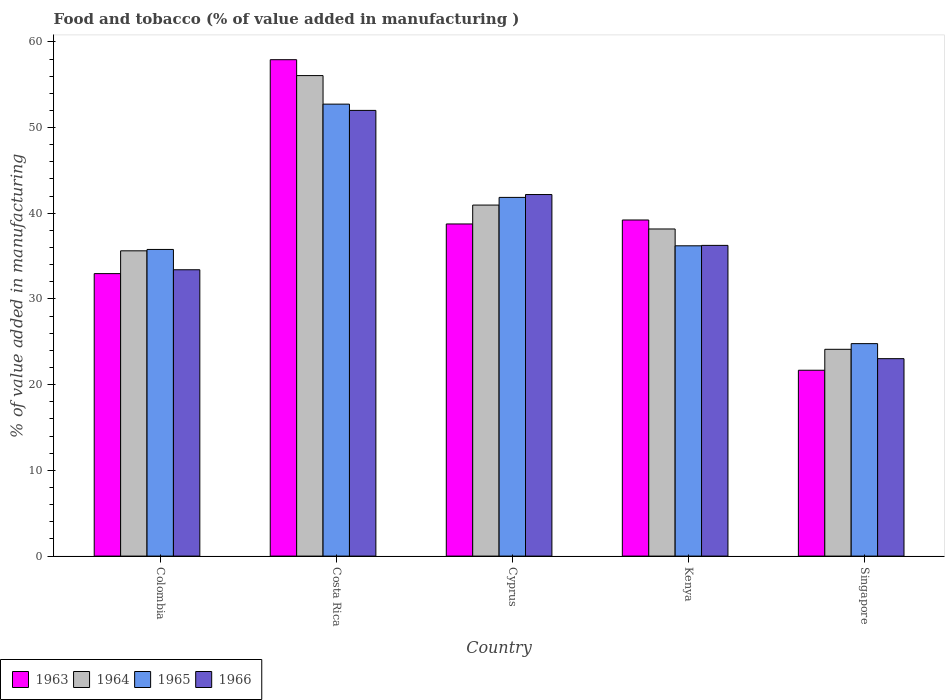How many groups of bars are there?
Ensure brevity in your answer.  5. Are the number of bars on each tick of the X-axis equal?
Make the answer very short. Yes. How many bars are there on the 2nd tick from the right?
Offer a very short reply. 4. What is the label of the 3rd group of bars from the left?
Offer a very short reply. Cyprus. What is the value added in manufacturing food and tobacco in 1964 in Cyprus?
Offer a very short reply. 40.96. Across all countries, what is the maximum value added in manufacturing food and tobacco in 1964?
Give a very brief answer. 56.07. Across all countries, what is the minimum value added in manufacturing food and tobacco in 1966?
Your answer should be very brief. 23.04. In which country was the value added in manufacturing food and tobacco in 1965 minimum?
Your answer should be very brief. Singapore. What is the total value added in manufacturing food and tobacco in 1964 in the graph?
Your answer should be very brief. 194.94. What is the difference between the value added in manufacturing food and tobacco in 1965 in Kenya and that in Singapore?
Provide a succinct answer. 11.41. What is the difference between the value added in manufacturing food and tobacco in 1964 in Costa Rica and the value added in manufacturing food and tobacco in 1965 in Singapore?
Offer a very short reply. 31.28. What is the average value added in manufacturing food and tobacco in 1966 per country?
Offer a terse response. 37.38. What is the difference between the value added in manufacturing food and tobacco of/in 1964 and value added in manufacturing food and tobacco of/in 1966 in Kenya?
Make the answer very short. 1.91. In how many countries, is the value added in manufacturing food and tobacco in 1965 greater than 50 %?
Your answer should be very brief. 1. What is the ratio of the value added in manufacturing food and tobacco in 1964 in Colombia to that in Singapore?
Give a very brief answer. 1.48. Is the difference between the value added in manufacturing food and tobacco in 1964 in Costa Rica and Kenya greater than the difference between the value added in manufacturing food and tobacco in 1966 in Costa Rica and Kenya?
Offer a terse response. Yes. What is the difference between the highest and the second highest value added in manufacturing food and tobacco in 1966?
Your answer should be compact. -9.82. What is the difference between the highest and the lowest value added in manufacturing food and tobacco in 1966?
Your response must be concise. 28.97. What does the 3rd bar from the left in Kenya represents?
Your response must be concise. 1965. What does the 1st bar from the right in Singapore represents?
Provide a succinct answer. 1966. Is it the case that in every country, the sum of the value added in manufacturing food and tobacco in 1966 and value added in manufacturing food and tobacco in 1963 is greater than the value added in manufacturing food and tobacco in 1964?
Offer a very short reply. Yes. Are all the bars in the graph horizontal?
Make the answer very short. No. How many countries are there in the graph?
Ensure brevity in your answer.  5. Does the graph contain any zero values?
Provide a succinct answer. No. Does the graph contain grids?
Your answer should be very brief. No. Where does the legend appear in the graph?
Offer a very short reply. Bottom left. What is the title of the graph?
Provide a succinct answer. Food and tobacco (% of value added in manufacturing ). Does "1995" appear as one of the legend labels in the graph?
Make the answer very short. No. What is the label or title of the Y-axis?
Offer a very short reply. % of value added in manufacturing. What is the % of value added in manufacturing in 1963 in Colombia?
Ensure brevity in your answer.  32.96. What is the % of value added in manufacturing of 1964 in Colombia?
Keep it short and to the point. 35.62. What is the % of value added in manufacturing of 1965 in Colombia?
Give a very brief answer. 35.78. What is the % of value added in manufacturing in 1966 in Colombia?
Your response must be concise. 33.41. What is the % of value added in manufacturing of 1963 in Costa Rica?
Give a very brief answer. 57.92. What is the % of value added in manufacturing in 1964 in Costa Rica?
Your answer should be compact. 56.07. What is the % of value added in manufacturing in 1965 in Costa Rica?
Keep it short and to the point. 52.73. What is the % of value added in manufacturing of 1966 in Costa Rica?
Provide a short and direct response. 52. What is the % of value added in manufacturing in 1963 in Cyprus?
Your answer should be very brief. 38.75. What is the % of value added in manufacturing of 1964 in Cyprus?
Make the answer very short. 40.96. What is the % of value added in manufacturing in 1965 in Cyprus?
Your answer should be very brief. 41.85. What is the % of value added in manufacturing of 1966 in Cyprus?
Offer a terse response. 42.19. What is the % of value added in manufacturing of 1963 in Kenya?
Your answer should be very brief. 39.22. What is the % of value added in manufacturing of 1964 in Kenya?
Offer a terse response. 38.17. What is the % of value added in manufacturing of 1965 in Kenya?
Provide a succinct answer. 36.2. What is the % of value added in manufacturing in 1966 in Kenya?
Give a very brief answer. 36.25. What is the % of value added in manufacturing of 1963 in Singapore?
Your response must be concise. 21.69. What is the % of value added in manufacturing of 1964 in Singapore?
Offer a terse response. 24.13. What is the % of value added in manufacturing of 1965 in Singapore?
Ensure brevity in your answer.  24.79. What is the % of value added in manufacturing in 1966 in Singapore?
Provide a succinct answer. 23.04. Across all countries, what is the maximum % of value added in manufacturing in 1963?
Your response must be concise. 57.92. Across all countries, what is the maximum % of value added in manufacturing in 1964?
Give a very brief answer. 56.07. Across all countries, what is the maximum % of value added in manufacturing of 1965?
Make the answer very short. 52.73. Across all countries, what is the maximum % of value added in manufacturing of 1966?
Your answer should be very brief. 52. Across all countries, what is the minimum % of value added in manufacturing of 1963?
Your answer should be compact. 21.69. Across all countries, what is the minimum % of value added in manufacturing of 1964?
Your answer should be compact. 24.13. Across all countries, what is the minimum % of value added in manufacturing of 1965?
Make the answer very short. 24.79. Across all countries, what is the minimum % of value added in manufacturing in 1966?
Your response must be concise. 23.04. What is the total % of value added in manufacturing of 1963 in the graph?
Make the answer very short. 190.54. What is the total % of value added in manufacturing in 1964 in the graph?
Make the answer very short. 194.94. What is the total % of value added in manufacturing in 1965 in the graph?
Offer a very short reply. 191.36. What is the total % of value added in manufacturing of 1966 in the graph?
Provide a succinct answer. 186.89. What is the difference between the % of value added in manufacturing in 1963 in Colombia and that in Costa Rica?
Provide a short and direct response. -24.96. What is the difference between the % of value added in manufacturing of 1964 in Colombia and that in Costa Rica?
Ensure brevity in your answer.  -20.45. What is the difference between the % of value added in manufacturing of 1965 in Colombia and that in Costa Rica?
Offer a terse response. -16.95. What is the difference between the % of value added in manufacturing of 1966 in Colombia and that in Costa Rica?
Give a very brief answer. -18.59. What is the difference between the % of value added in manufacturing of 1963 in Colombia and that in Cyprus?
Your answer should be compact. -5.79. What is the difference between the % of value added in manufacturing in 1964 in Colombia and that in Cyprus?
Your answer should be compact. -5.34. What is the difference between the % of value added in manufacturing in 1965 in Colombia and that in Cyprus?
Your answer should be compact. -6.07. What is the difference between the % of value added in manufacturing in 1966 in Colombia and that in Cyprus?
Your answer should be compact. -8.78. What is the difference between the % of value added in manufacturing of 1963 in Colombia and that in Kenya?
Ensure brevity in your answer.  -6.26. What is the difference between the % of value added in manufacturing of 1964 in Colombia and that in Kenya?
Ensure brevity in your answer.  -2.55. What is the difference between the % of value added in manufacturing in 1965 in Colombia and that in Kenya?
Keep it short and to the point. -0.42. What is the difference between the % of value added in manufacturing in 1966 in Colombia and that in Kenya?
Your answer should be very brief. -2.84. What is the difference between the % of value added in manufacturing in 1963 in Colombia and that in Singapore?
Your response must be concise. 11.27. What is the difference between the % of value added in manufacturing in 1964 in Colombia and that in Singapore?
Give a very brief answer. 11.49. What is the difference between the % of value added in manufacturing in 1965 in Colombia and that in Singapore?
Provide a short and direct response. 10.99. What is the difference between the % of value added in manufacturing in 1966 in Colombia and that in Singapore?
Make the answer very short. 10.37. What is the difference between the % of value added in manufacturing of 1963 in Costa Rica and that in Cyprus?
Ensure brevity in your answer.  19.17. What is the difference between the % of value added in manufacturing of 1964 in Costa Rica and that in Cyprus?
Ensure brevity in your answer.  15.11. What is the difference between the % of value added in manufacturing of 1965 in Costa Rica and that in Cyprus?
Make the answer very short. 10.88. What is the difference between the % of value added in manufacturing of 1966 in Costa Rica and that in Cyprus?
Ensure brevity in your answer.  9.82. What is the difference between the % of value added in manufacturing in 1963 in Costa Rica and that in Kenya?
Offer a very short reply. 18.7. What is the difference between the % of value added in manufacturing in 1964 in Costa Rica and that in Kenya?
Ensure brevity in your answer.  17.9. What is the difference between the % of value added in manufacturing of 1965 in Costa Rica and that in Kenya?
Your answer should be compact. 16.53. What is the difference between the % of value added in manufacturing in 1966 in Costa Rica and that in Kenya?
Your response must be concise. 15.75. What is the difference between the % of value added in manufacturing of 1963 in Costa Rica and that in Singapore?
Make the answer very short. 36.23. What is the difference between the % of value added in manufacturing in 1964 in Costa Rica and that in Singapore?
Provide a succinct answer. 31.94. What is the difference between the % of value added in manufacturing in 1965 in Costa Rica and that in Singapore?
Provide a succinct answer. 27.94. What is the difference between the % of value added in manufacturing in 1966 in Costa Rica and that in Singapore?
Offer a terse response. 28.97. What is the difference between the % of value added in manufacturing in 1963 in Cyprus and that in Kenya?
Provide a succinct answer. -0.46. What is the difference between the % of value added in manufacturing in 1964 in Cyprus and that in Kenya?
Your answer should be very brief. 2.79. What is the difference between the % of value added in manufacturing in 1965 in Cyprus and that in Kenya?
Ensure brevity in your answer.  5.65. What is the difference between the % of value added in manufacturing of 1966 in Cyprus and that in Kenya?
Offer a very short reply. 5.93. What is the difference between the % of value added in manufacturing in 1963 in Cyprus and that in Singapore?
Ensure brevity in your answer.  17.07. What is the difference between the % of value added in manufacturing in 1964 in Cyprus and that in Singapore?
Your response must be concise. 16.83. What is the difference between the % of value added in manufacturing of 1965 in Cyprus and that in Singapore?
Keep it short and to the point. 17.06. What is the difference between the % of value added in manufacturing in 1966 in Cyprus and that in Singapore?
Your answer should be compact. 19.15. What is the difference between the % of value added in manufacturing of 1963 in Kenya and that in Singapore?
Your answer should be very brief. 17.53. What is the difference between the % of value added in manufacturing in 1964 in Kenya and that in Singapore?
Your answer should be compact. 14.04. What is the difference between the % of value added in manufacturing in 1965 in Kenya and that in Singapore?
Your answer should be very brief. 11.41. What is the difference between the % of value added in manufacturing of 1966 in Kenya and that in Singapore?
Offer a very short reply. 13.22. What is the difference between the % of value added in manufacturing in 1963 in Colombia and the % of value added in manufacturing in 1964 in Costa Rica?
Provide a short and direct response. -23.11. What is the difference between the % of value added in manufacturing of 1963 in Colombia and the % of value added in manufacturing of 1965 in Costa Rica?
Keep it short and to the point. -19.77. What is the difference between the % of value added in manufacturing of 1963 in Colombia and the % of value added in manufacturing of 1966 in Costa Rica?
Your answer should be compact. -19.04. What is the difference between the % of value added in manufacturing in 1964 in Colombia and the % of value added in manufacturing in 1965 in Costa Rica?
Provide a short and direct response. -17.11. What is the difference between the % of value added in manufacturing of 1964 in Colombia and the % of value added in manufacturing of 1966 in Costa Rica?
Provide a short and direct response. -16.38. What is the difference between the % of value added in manufacturing in 1965 in Colombia and the % of value added in manufacturing in 1966 in Costa Rica?
Your response must be concise. -16.22. What is the difference between the % of value added in manufacturing of 1963 in Colombia and the % of value added in manufacturing of 1964 in Cyprus?
Your answer should be very brief. -8. What is the difference between the % of value added in manufacturing in 1963 in Colombia and the % of value added in manufacturing in 1965 in Cyprus?
Provide a succinct answer. -8.89. What is the difference between the % of value added in manufacturing of 1963 in Colombia and the % of value added in manufacturing of 1966 in Cyprus?
Offer a very short reply. -9.23. What is the difference between the % of value added in manufacturing of 1964 in Colombia and the % of value added in manufacturing of 1965 in Cyprus?
Ensure brevity in your answer.  -6.23. What is the difference between the % of value added in manufacturing in 1964 in Colombia and the % of value added in manufacturing in 1966 in Cyprus?
Your answer should be compact. -6.57. What is the difference between the % of value added in manufacturing in 1965 in Colombia and the % of value added in manufacturing in 1966 in Cyprus?
Give a very brief answer. -6.41. What is the difference between the % of value added in manufacturing of 1963 in Colombia and the % of value added in manufacturing of 1964 in Kenya?
Your answer should be very brief. -5.21. What is the difference between the % of value added in manufacturing in 1963 in Colombia and the % of value added in manufacturing in 1965 in Kenya?
Your answer should be compact. -3.24. What is the difference between the % of value added in manufacturing in 1963 in Colombia and the % of value added in manufacturing in 1966 in Kenya?
Offer a very short reply. -3.29. What is the difference between the % of value added in manufacturing of 1964 in Colombia and the % of value added in manufacturing of 1965 in Kenya?
Your response must be concise. -0.58. What is the difference between the % of value added in manufacturing in 1964 in Colombia and the % of value added in manufacturing in 1966 in Kenya?
Your answer should be compact. -0.63. What is the difference between the % of value added in manufacturing in 1965 in Colombia and the % of value added in manufacturing in 1966 in Kenya?
Provide a short and direct response. -0.47. What is the difference between the % of value added in manufacturing of 1963 in Colombia and the % of value added in manufacturing of 1964 in Singapore?
Keep it short and to the point. 8.83. What is the difference between the % of value added in manufacturing of 1963 in Colombia and the % of value added in manufacturing of 1965 in Singapore?
Offer a very short reply. 8.17. What is the difference between the % of value added in manufacturing in 1963 in Colombia and the % of value added in manufacturing in 1966 in Singapore?
Provide a short and direct response. 9.92. What is the difference between the % of value added in manufacturing of 1964 in Colombia and the % of value added in manufacturing of 1965 in Singapore?
Ensure brevity in your answer.  10.83. What is the difference between the % of value added in manufacturing in 1964 in Colombia and the % of value added in manufacturing in 1966 in Singapore?
Provide a succinct answer. 12.58. What is the difference between the % of value added in manufacturing in 1965 in Colombia and the % of value added in manufacturing in 1966 in Singapore?
Offer a terse response. 12.74. What is the difference between the % of value added in manufacturing in 1963 in Costa Rica and the % of value added in manufacturing in 1964 in Cyprus?
Give a very brief answer. 16.96. What is the difference between the % of value added in manufacturing of 1963 in Costa Rica and the % of value added in manufacturing of 1965 in Cyprus?
Your answer should be compact. 16.07. What is the difference between the % of value added in manufacturing in 1963 in Costa Rica and the % of value added in manufacturing in 1966 in Cyprus?
Give a very brief answer. 15.73. What is the difference between the % of value added in manufacturing of 1964 in Costa Rica and the % of value added in manufacturing of 1965 in Cyprus?
Give a very brief answer. 14.21. What is the difference between the % of value added in manufacturing in 1964 in Costa Rica and the % of value added in manufacturing in 1966 in Cyprus?
Your answer should be very brief. 13.88. What is the difference between the % of value added in manufacturing in 1965 in Costa Rica and the % of value added in manufacturing in 1966 in Cyprus?
Give a very brief answer. 10.55. What is the difference between the % of value added in manufacturing in 1963 in Costa Rica and the % of value added in manufacturing in 1964 in Kenya?
Give a very brief answer. 19.75. What is the difference between the % of value added in manufacturing in 1963 in Costa Rica and the % of value added in manufacturing in 1965 in Kenya?
Make the answer very short. 21.72. What is the difference between the % of value added in manufacturing in 1963 in Costa Rica and the % of value added in manufacturing in 1966 in Kenya?
Your answer should be very brief. 21.67. What is the difference between the % of value added in manufacturing of 1964 in Costa Rica and the % of value added in manufacturing of 1965 in Kenya?
Make the answer very short. 19.86. What is the difference between the % of value added in manufacturing of 1964 in Costa Rica and the % of value added in manufacturing of 1966 in Kenya?
Offer a terse response. 19.81. What is the difference between the % of value added in manufacturing of 1965 in Costa Rica and the % of value added in manufacturing of 1966 in Kenya?
Keep it short and to the point. 16.48. What is the difference between the % of value added in manufacturing of 1963 in Costa Rica and the % of value added in manufacturing of 1964 in Singapore?
Offer a terse response. 33.79. What is the difference between the % of value added in manufacturing in 1963 in Costa Rica and the % of value added in manufacturing in 1965 in Singapore?
Your response must be concise. 33.13. What is the difference between the % of value added in manufacturing in 1963 in Costa Rica and the % of value added in manufacturing in 1966 in Singapore?
Your answer should be very brief. 34.88. What is the difference between the % of value added in manufacturing in 1964 in Costa Rica and the % of value added in manufacturing in 1965 in Singapore?
Give a very brief answer. 31.28. What is the difference between the % of value added in manufacturing in 1964 in Costa Rica and the % of value added in manufacturing in 1966 in Singapore?
Make the answer very short. 33.03. What is the difference between the % of value added in manufacturing of 1965 in Costa Rica and the % of value added in manufacturing of 1966 in Singapore?
Ensure brevity in your answer.  29.7. What is the difference between the % of value added in manufacturing of 1963 in Cyprus and the % of value added in manufacturing of 1964 in Kenya?
Provide a short and direct response. 0.59. What is the difference between the % of value added in manufacturing of 1963 in Cyprus and the % of value added in manufacturing of 1965 in Kenya?
Ensure brevity in your answer.  2.55. What is the difference between the % of value added in manufacturing of 1963 in Cyprus and the % of value added in manufacturing of 1966 in Kenya?
Provide a succinct answer. 2.5. What is the difference between the % of value added in manufacturing of 1964 in Cyprus and the % of value added in manufacturing of 1965 in Kenya?
Offer a very short reply. 4.75. What is the difference between the % of value added in manufacturing in 1964 in Cyprus and the % of value added in manufacturing in 1966 in Kenya?
Provide a short and direct response. 4.7. What is the difference between the % of value added in manufacturing of 1965 in Cyprus and the % of value added in manufacturing of 1966 in Kenya?
Make the answer very short. 5.6. What is the difference between the % of value added in manufacturing of 1963 in Cyprus and the % of value added in manufacturing of 1964 in Singapore?
Ensure brevity in your answer.  14.63. What is the difference between the % of value added in manufacturing of 1963 in Cyprus and the % of value added in manufacturing of 1965 in Singapore?
Provide a succinct answer. 13.96. What is the difference between the % of value added in manufacturing in 1963 in Cyprus and the % of value added in manufacturing in 1966 in Singapore?
Your response must be concise. 15.72. What is the difference between the % of value added in manufacturing in 1964 in Cyprus and the % of value added in manufacturing in 1965 in Singapore?
Your answer should be compact. 16.17. What is the difference between the % of value added in manufacturing of 1964 in Cyprus and the % of value added in manufacturing of 1966 in Singapore?
Make the answer very short. 17.92. What is the difference between the % of value added in manufacturing in 1965 in Cyprus and the % of value added in manufacturing in 1966 in Singapore?
Your answer should be compact. 18.82. What is the difference between the % of value added in manufacturing of 1963 in Kenya and the % of value added in manufacturing of 1964 in Singapore?
Offer a very short reply. 15.09. What is the difference between the % of value added in manufacturing in 1963 in Kenya and the % of value added in manufacturing in 1965 in Singapore?
Offer a terse response. 14.43. What is the difference between the % of value added in manufacturing of 1963 in Kenya and the % of value added in manufacturing of 1966 in Singapore?
Give a very brief answer. 16.18. What is the difference between the % of value added in manufacturing in 1964 in Kenya and the % of value added in manufacturing in 1965 in Singapore?
Your answer should be compact. 13.38. What is the difference between the % of value added in manufacturing in 1964 in Kenya and the % of value added in manufacturing in 1966 in Singapore?
Offer a very short reply. 15.13. What is the difference between the % of value added in manufacturing of 1965 in Kenya and the % of value added in manufacturing of 1966 in Singapore?
Offer a terse response. 13.17. What is the average % of value added in manufacturing of 1963 per country?
Your response must be concise. 38.11. What is the average % of value added in manufacturing of 1964 per country?
Offer a very short reply. 38.99. What is the average % of value added in manufacturing in 1965 per country?
Provide a short and direct response. 38.27. What is the average % of value added in manufacturing of 1966 per country?
Offer a very short reply. 37.38. What is the difference between the % of value added in manufacturing in 1963 and % of value added in manufacturing in 1964 in Colombia?
Offer a terse response. -2.66. What is the difference between the % of value added in manufacturing in 1963 and % of value added in manufacturing in 1965 in Colombia?
Make the answer very short. -2.82. What is the difference between the % of value added in manufacturing of 1963 and % of value added in manufacturing of 1966 in Colombia?
Make the answer very short. -0.45. What is the difference between the % of value added in manufacturing in 1964 and % of value added in manufacturing in 1965 in Colombia?
Provide a succinct answer. -0.16. What is the difference between the % of value added in manufacturing of 1964 and % of value added in manufacturing of 1966 in Colombia?
Provide a succinct answer. 2.21. What is the difference between the % of value added in manufacturing in 1965 and % of value added in manufacturing in 1966 in Colombia?
Offer a very short reply. 2.37. What is the difference between the % of value added in manufacturing of 1963 and % of value added in manufacturing of 1964 in Costa Rica?
Offer a terse response. 1.85. What is the difference between the % of value added in manufacturing of 1963 and % of value added in manufacturing of 1965 in Costa Rica?
Make the answer very short. 5.19. What is the difference between the % of value added in manufacturing in 1963 and % of value added in manufacturing in 1966 in Costa Rica?
Provide a succinct answer. 5.92. What is the difference between the % of value added in manufacturing of 1964 and % of value added in manufacturing of 1965 in Costa Rica?
Offer a terse response. 3.33. What is the difference between the % of value added in manufacturing in 1964 and % of value added in manufacturing in 1966 in Costa Rica?
Offer a terse response. 4.06. What is the difference between the % of value added in manufacturing in 1965 and % of value added in manufacturing in 1966 in Costa Rica?
Make the answer very short. 0.73. What is the difference between the % of value added in manufacturing of 1963 and % of value added in manufacturing of 1964 in Cyprus?
Provide a short and direct response. -2.2. What is the difference between the % of value added in manufacturing in 1963 and % of value added in manufacturing in 1965 in Cyprus?
Your answer should be compact. -3.1. What is the difference between the % of value added in manufacturing in 1963 and % of value added in manufacturing in 1966 in Cyprus?
Provide a short and direct response. -3.43. What is the difference between the % of value added in manufacturing in 1964 and % of value added in manufacturing in 1965 in Cyprus?
Give a very brief answer. -0.9. What is the difference between the % of value added in manufacturing in 1964 and % of value added in manufacturing in 1966 in Cyprus?
Keep it short and to the point. -1.23. What is the difference between the % of value added in manufacturing of 1963 and % of value added in manufacturing of 1964 in Kenya?
Keep it short and to the point. 1.05. What is the difference between the % of value added in manufacturing of 1963 and % of value added in manufacturing of 1965 in Kenya?
Your answer should be compact. 3.01. What is the difference between the % of value added in manufacturing in 1963 and % of value added in manufacturing in 1966 in Kenya?
Keep it short and to the point. 2.96. What is the difference between the % of value added in manufacturing in 1964 and % of value added in manufacturing in 1965 in Kenya?
Offer a terse response. 1.96. What is the difference between the % of value added in manufacturing of 1964 and % of value added in manufacturing of 1966 in Kenya?
Keep it short and to the point. 1.91. What is the difference between the % of value added in manufacturing of 1965 and % of value added in manufacturing of 1966 in Kenya?
Make the answer very short. -0.05. What is the difference between the % of value added in manufacturing in 1963 and % of value added in manufacturing in 1964 in Singapore?
Keep it short and to the point. -2.44. What is the difference between the % of value added in manufacturing in 1963 and % of value added in manufacturing in 1965 in Singapore?
Keep it short and to the point. -3.1. What is the difference between the % of value added in manufacturing in 1963 and % of value added in manufacturing in 1966 in Singapore?
Your response must be concise. -1.35. What is the difference between the % of value added in manufacturing in 1964 and % of value added in manufacturing in 1965 in Singapore?
Make the answer very short. -0.66. What is the difference between the % of value added in manufacturing in 1964 and % of value added in manufacturing in 1966 in Singapore?
Offer a terse response. 1.09. What is the difference between the % of value added in manufacturing of 1965 and % of value added in manufacturing of 1966 in Singapore?
Keep it short and to the point. 1.75. What is the ratio of the % of value added in manufacturing of 1963 in Colombia to that in Costa Rica?
Your answer should be compact. 0.57. What is the ratio of the % of value added in manufacturing of 1964 in Colombia to that in Costa Rica?
Your response must be concise. 0.64. What is the ratio of the % of value added in manufacturing in 1965 in Colombia to that in Costa Rica?
Offer a very short reply. 0.68. What is the ratio of the % of value added in manufacturing of 1966 in Colombia to that in Costa Rica?
Your response must be concise. 0.64. What is the ratio of the % of value added in manufacturing of 1963 in Colombia to that in Cyprus?
Offer a very short reply. 0.85. What is the ratio of the % of value added in manufacturing of 1964 in Colombia to that in Cyprus?
Provide a succinct answer. 0.87. What is the ratio of the % of value added in manufacturing of 1965 in Colombia to that in Cyprus?
Your response must be concise. 0.85. What is the ratio of the % of value added in manufacturing of 1966 in Colombia to that in Cyprus?
Provide a succinct answer. 0.79. What is the ratio of the % of value added in manufacturing of 1963 in Colombia to that in Kenya?
Give a very brief answer. 0.84. What is the ratio of the % of value added in manufacturing of 1964 in Colombia to that in Kenya?
Your answer should be compact. 0.93. What is the ratio of the % of value added in manufacturing in 1965 in Colombia to that in Kenya?
Your answer should be compact. 0.99. What is the ratio of the % of value added in manufacturing of 1966 in Colombia to that in Kenya?
Keep it short and to the point. 0.92. What is the ratio of the % of value added in manufacturing of 1963 in Colombia to that in Singapore?
Your answer should be compact. 1.52. What is the ratio of the % of value added in manufacturing of 1964 in Colombia to that in Singapore?
Provide a short and direct response. 1.48. What is the ratio of the % of value added in manufacturing of 1965 in Colombia to that in Singapore?
Keep it short and to the point. 1.44. What is the ratio of the % of value added in manufacturing of 1966 in Colombia to that in Singapore?
Give a very brief answer. 1.45. What is the ratio of the % of value added in manufacturing of 1963 in Costa Rica to that in Cyprus?
Provide a succinct answer. 1.49. What is the ratio of the % of value added in manufacturing in 1964 in Costa Rica to that in Cyprus?
Make the answer very short. 1.37. What is the ratio of the % of value added in manufacturing in 1965 in Costa Rica to that in Cyprus?
Provide a short and direct response. 1.26. What is the ratio of the % of value added in manufacturing of 1966 in Costa Rica to that in Cyprus?
Provide a succinct answer. 1.23. What is the ratio of the % of value added in manufacturing of 1963 in Costa Rica to that in Kenya?
Make the answer very short. 1.48. What is the ratio of the % of value added in manufacturing in 1964 in Costa Rica to that in Kenya?
Your answer should be compact. 1.47. What is the ratio of the % of value added in manufacturing in 1965 in Costa Rica to that in Kenya?
Your response must be concise. 1.46. What is the ratio of the % of value added in manufacturing in 1966 in Costa Rica to that in Kenya?
Provide a succinct answer. 1.43. What is the ratio of the % of value added in manufacturing in 1963 in Costa Rica to that in Singapore?
Ensure brevity in your answer.  2.67. What is the ratio of the % of value added in manufacturing of 1964 in Costa Rica to that in Singapore?
Offer a very short reply. 2.32. What is the ratio of the % of value added in manufacturing in 1965 in Costa Rica to that in Singapore?
Provide a succinct answer. 2.13. What is the ratio of the % of value added in manufacturing of 1966 in Costa Rica to that in Singapore?
Keep it short and to the point. 2.26. What is the ratio of the % of value added in manufacturing in 1964 in Cyprus to that in Kenya?
Provide a succinct answer. 1.07. What is the ratio of the % of value added in manufacturing of 1965 in Cyprus to that in Kenya?
Ensure brevity in your answer.  1.16. What is the ratio of the % of value added in manufacturing in 1966 in Cyprus to that in Kenya?
Offer a terse response. 1.16. What is the ratio of the % of value added in manufacturing in 1963 in Cyprus to that in Singapore?
Ensure brevity in your answer.  1.79. What is the ratio of the % of value added in manufacturing of 1964 in Cyprus to that in Singapore?
Ensure brevity in your answer.  1.7. What is the ratio of the % of value added in manufacturing in 1965 in Cyprus to that in Singapore?
Your answer should be compact. 1.69. What is the ratio of the % of value added in manufacturing in 1966 in Cyprus to that in Singapore?
Provide a short and direct response. 1.83. What is the ratio of the % of value added in manufacturing of 1963 in Kenya to that in Singapore?
Keep it short and to the point. 1.81. What is the ratio of the % of value added in manufacturing of 1964 in Kenya to that in Singapore?
Keep it short and to the point. 1.58. What is the ratio of the % of value added in manufacturing of 1965 in Kenya to that in Singapore?
Ensure brevity in your answer.  1.46. What is the ratio of the % of value added in manufacturing in 1966 in Kenya to that in Singapore?
Provide a succinct answer. 1.57. What is the difference between the highest and the second highest % of value added in manufacturing in 1963?
Ensure brevity in your answer.  18.7. What is the difference between the highest and the second highest % of value added in manufacturing in 1964?
Offer a terse response. 15.11. What is the difference between the highest and the second highest % of value added in manufacturing in 1965?
Provide a short and direct response. 10.88. What is the difference between the highest and the second highest % of value added in manufacturing of 1966?
Keep it short and to the point. 9.82. What is the difference between the highest and the lowest % of value added in manufacturing of 1963?
Provide a short and direct response. 36.23. What is the difference between the highest and the lowest % of value added in manufacturing in 1964?
Your response must be concise. 31.94. What is the difference between the highest and the lowest % of value added in manufacturing of 1965?
Make the answer very short. 27.94. What is the difference between the highest and the lowest % of value added in manufacturing in 1966?
Give a very brief answer. 28.97. 